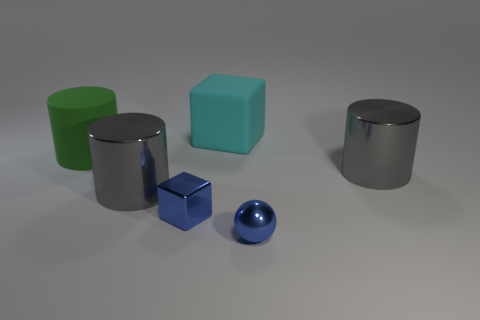Is the size of the green matte cylinder the same as the gray metal object on the right side of the small blue block?
Your answer should be very brief. Yes. How many other things are there of the same color as the small metal sphere?
Ensure brevity in your answer.  1. Is the number of big cyan matte things right of the large cube greater than the number of large matte cubes?
Provide a succinct answer. No. What color is the metal thing that is behind the large metallic cylinder that is in front of the cylinder on the right side of the blue metal sphere?
Your answer should be very brief. Gray. Is the material of the blue ball the same as the small blue cube?
Give a very brief answer. Yes. Is there a gray thing that has the same size as the green matte thing?
Offer a very short reply. Yes. There is a blue object that is the same size as the metallic ball; what is its material?
Your answer should be compact. Metal. Is there another large thing that has the same shape as the big cyan object?
Give a very brief answer. No. What material is the ball that is the same color as the shiny block?
Give a very brief answer. Metal. What shape is the matte object that is in front of the big cube?
Offer a very short reply. Cylinder. 